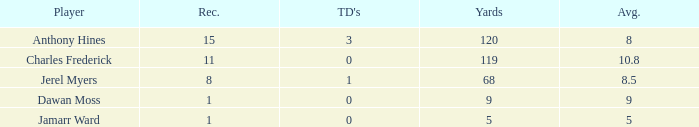What is the highest number of TDs when the Avg is larger than 8.5 and the Rec is less than 1? None. 